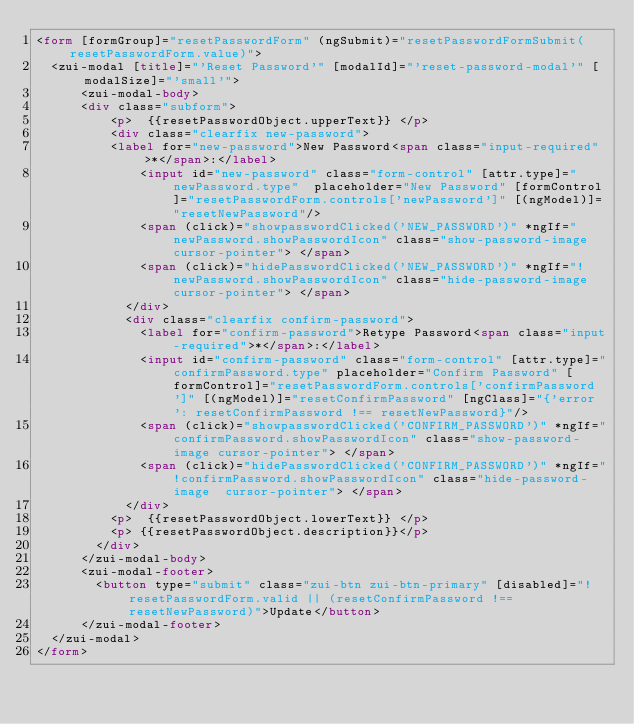<code> <loc_0><loc_0><loc_500><loc_500><_HTML_><form [formGroup]="resetPasswordForm" (ngSubmit)="resetPasswordFormSubmit(resetPasswordForm.value)">
	<zui-modal [title]="'Reset Password'" [modalId]="'reset-password-modal'" [modalSize]="'small'">
	    <zui-modal-body>
	 		<div class="subform">
		     	<p>  {{resetPasswordObject.upperText}} </p>
			    <div class="clearfix new-password">
					<label for="new-password">New Password<span class="input-required">*</span>:</label>
	        		<input id="new-password" class="form-control" [attr.type]="newPassword.type"  placeholder="New Password" [formControl]="resetPasswordForm.controls['newPassword']" [(ngModel)]="resetNewPassword"/>
	        		<span (click)="showpasswordClicked('NEW_PASSWORD')" *ngIf="newPassword.showPasswordIcon" class="show-password-image cursor-pointer"> </span>
	        		<span (click)="hidePasswordClicked('NEW_PASSWORD')" *ngIf="!newPassword.showPasswordIcon" class="hide-password-image  cursor-pointer"> </span>
	        	</div>
	        	<div class="clearfix confirm-password">
	        		<label for="confirm-password">Retype Password<span class="input-required">*</span>:</label>
	        		<input id="confirm-password" class="form-control" [attr.type]="confirmPassword.type" placeholder="Confirm Password" [formControl]="resetPasswordForm.controls['confirmPassword']" [(ngModel)]="resetConfirmPassword" [ngClass]="{'error': resetConfirmPassword !== resetNewPassword}"/>
	        		<span (click)="showpasswordClicked('CONFIRM_PASSWORD')" *ngIf="confirmPassword.showPasswordIcon" class="show-password-image cursor-pointer"> </span>
	        		<span (click)="hidePasswordClicked('CONFIRM_PASSWORD')" *ngIf="!confirmPassword.showPasswordIcon" class="hide-password-image  cursor-pointer"> </span>
	        	</div>
	    		<p>  {{resetPasswordObject.lowerText}} </p>
	    		<p> {{resetPasswordObject.description}}</p>
		    </div>
	    </zui-modal-body>
	    <zui-modal-footer>
		    <button type="submit" class="zui-btn zui-btn-primary" [disabled]="!resetPasswordForm.valid || (resetConfirmPassword !== resetNewPassword)">Update</button>
	    </zui-modal-footer>
	</zui-modal>
</form>

</code> 